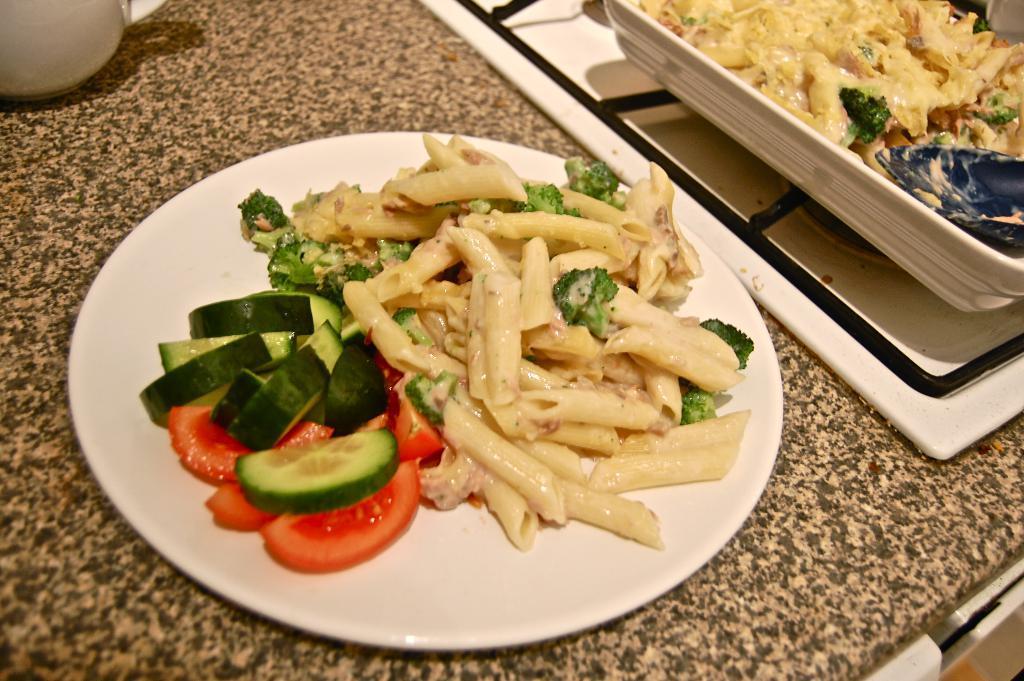Can you describe this image briefly? In the center of the image we can see salad in plate placed on the table. On the right side of the image we can see food in the bowl. At the top left corner we can see cup. 